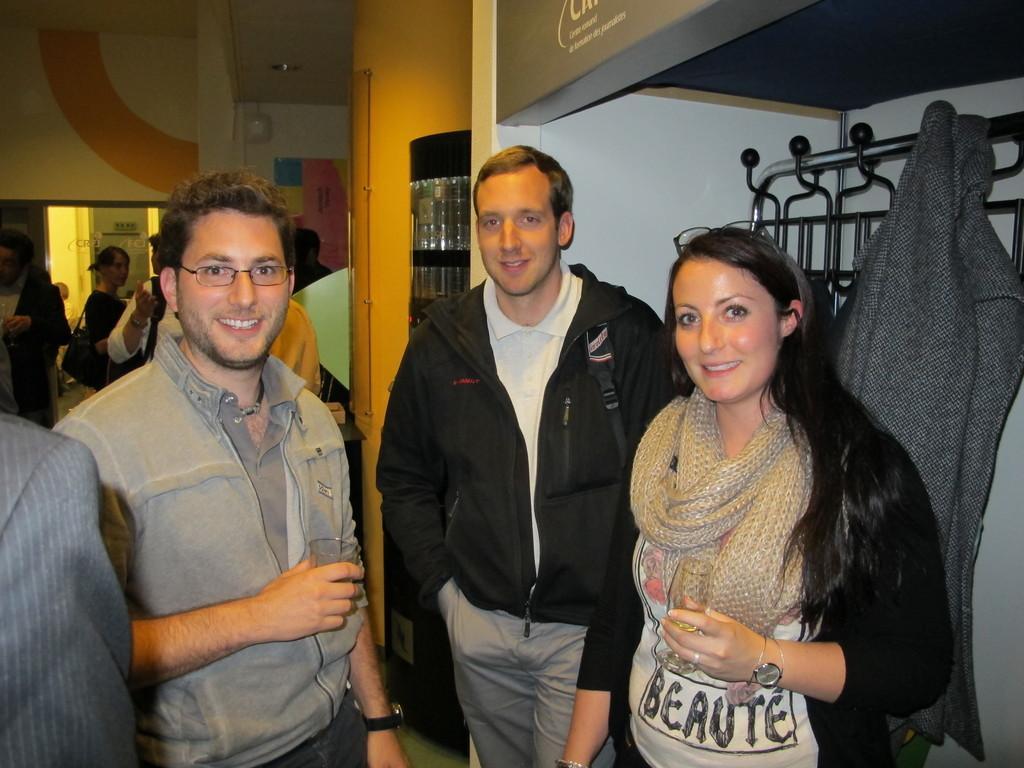In one or two sentences, can you explain what this image depicts? In this image, we can see people standing and smiling and holding glasses. In the background, there are some other people. On the right, we can see a hanger and a coat is hanging to it. At the top, there is roof. 